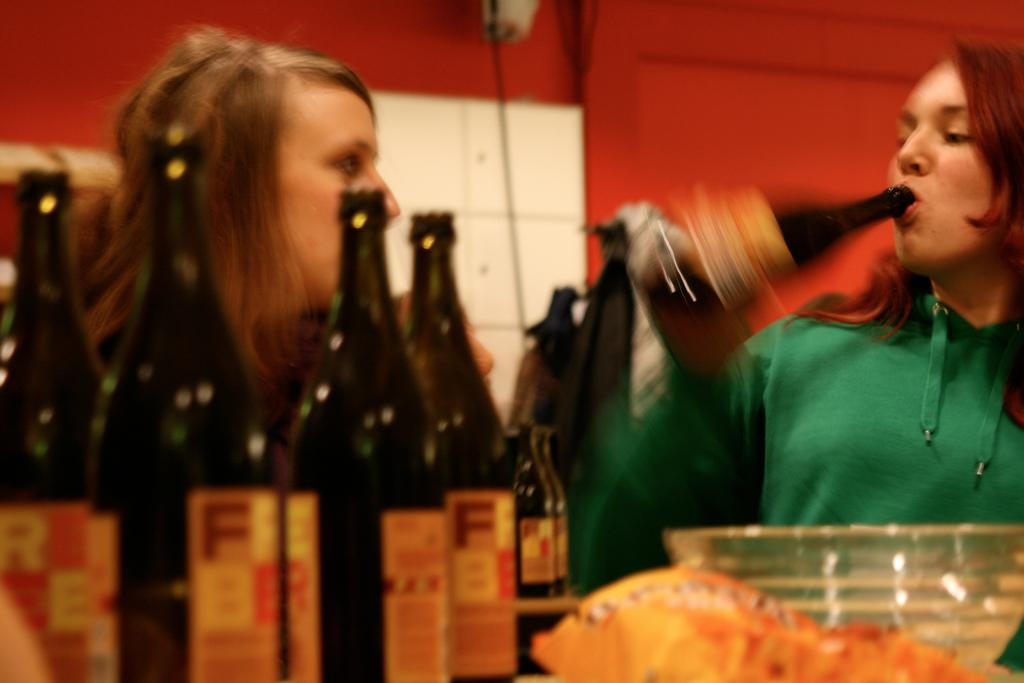How many people are in the image? There are two persons in the image. What is one person holding in the image? One person is holding a bottle. Are there any other bottles visible in the image? Yes, there are bottles visible in the image. What else can be seen in the image besides the people and bottles? There is a bowl in the image. What is visible in the background of the image? There is a wall in the background of the image. Can you see a rat hiding behind the wall in the image? There is no rat visible in the image, nor is there any indication of a rat's presence. 